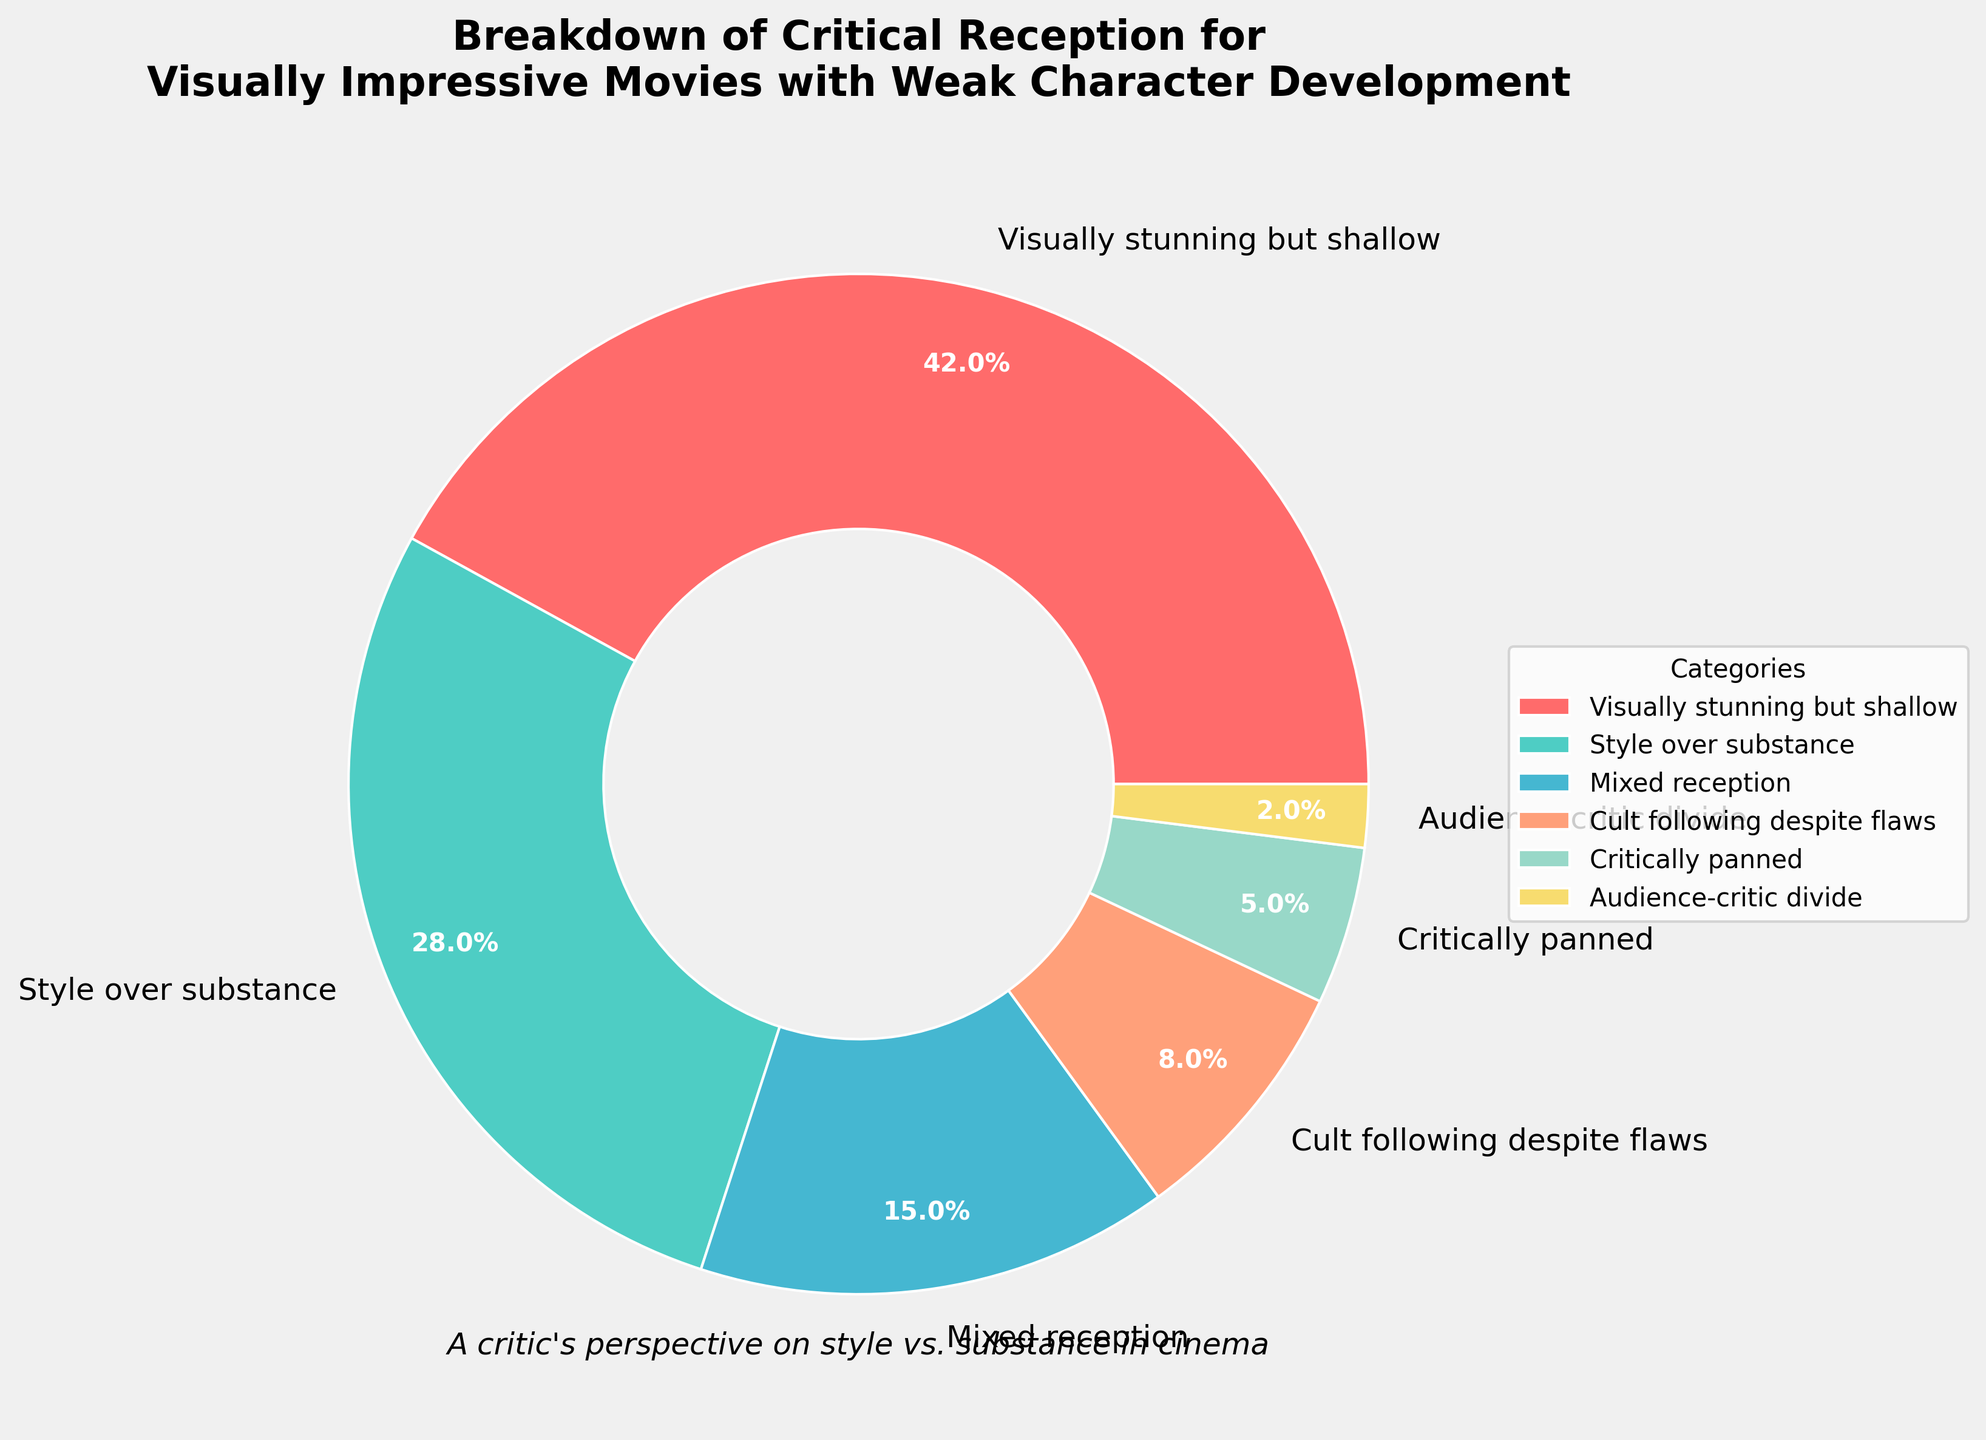What percentage of critics believe that the movies are visually stunning but lack depth? The category "Visually stunning but shallow" shows the percentage value directly on the pie chart.
Answer: 42% What is the combined percentage of critics who think that the films are either "Visually stunning but shallow" or have "Style over substance"? Sum the percentages of the two categories: 42% (Visually stunning but shallow) + 28% (Style over substance) = 70%
Answer: 70% Which category has the least support, and what is its percentage? The pie chart labels indicate that the "Audience-critic divide" category has the smallest percentage value of 2%.
Answer: Audience-critic divide, 2% How much more do the critics categorize movies as "Visually stunning but shallow" compared to being "Critically panned"? Subtract the percentage of "Critically panned" (5%) from "Visually stunning but shallow" (42%): 42% - 5% = 37%
Answer: 37% What percentage of critics have a mixed reception to these films? The category "Mixed reception" shows the percentage value directly on the pie chart.
Answer: 15% Do more critics believe in a "Cult following despite flaws" than those who think the movies received a "Critically panned" reception? Compare the percentages of "Cult following despite flaws" (8%) and "Critically panned" (5%). 8% is greater than 5%.
Answer: Yes What is the average percentage of the categories that receive positive reception, which includes "Visually stunning but shallow," "Style over substance," and "Cult following despite flaws"? Add the percentages of the three categories and divide by the number of categories: (42% + 28% + 8%) / 3 = 78% / 3 = 26%
Answer: 26% How does the "Mixed reception" compare to the combined percentage of "Critically panned" and "Audience-critic divide"? Sum the percentages of "Critically panned" (5%) and "Audience-critic divide" (2%), then compare to "Mixed reception" (15%): 5% + 2% = 7%. Since 15% is greater than 7%, the "Mixed reception" is higher.
Answer: Mixed reception is higher What is the second most common critical perspective on the movies shown in the pie chart? Based on the percentages, the most common is "Visually stunning but shallow" (42%), followed by "Style over substance" (28%).
Answer: Style over substance 